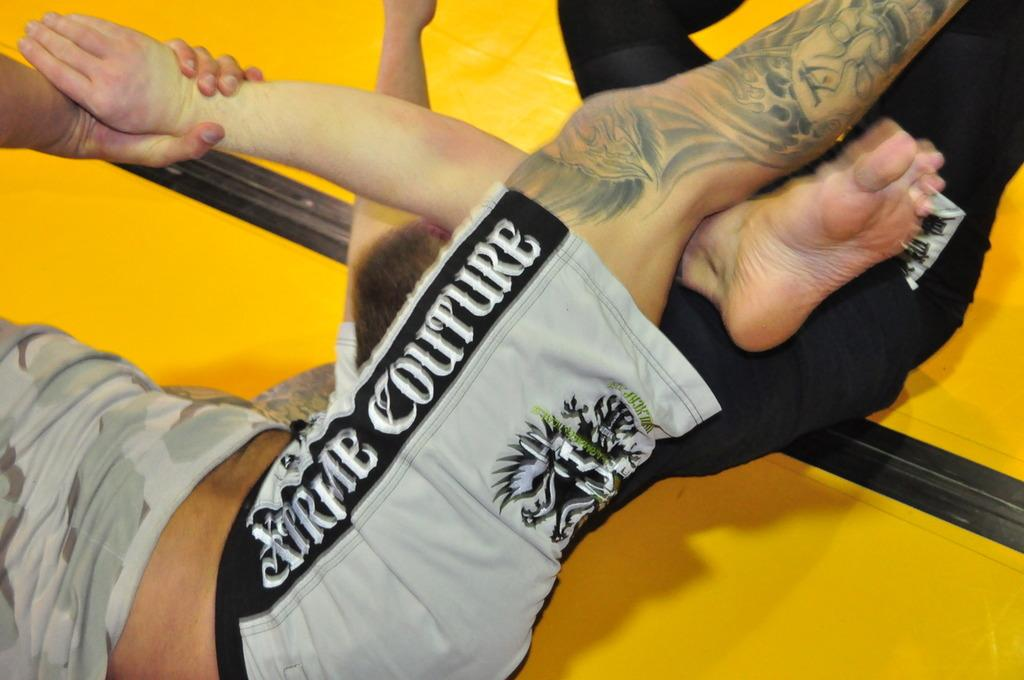<image>
Summarize the visual content of the image. the name Couture is on the side of the pants 